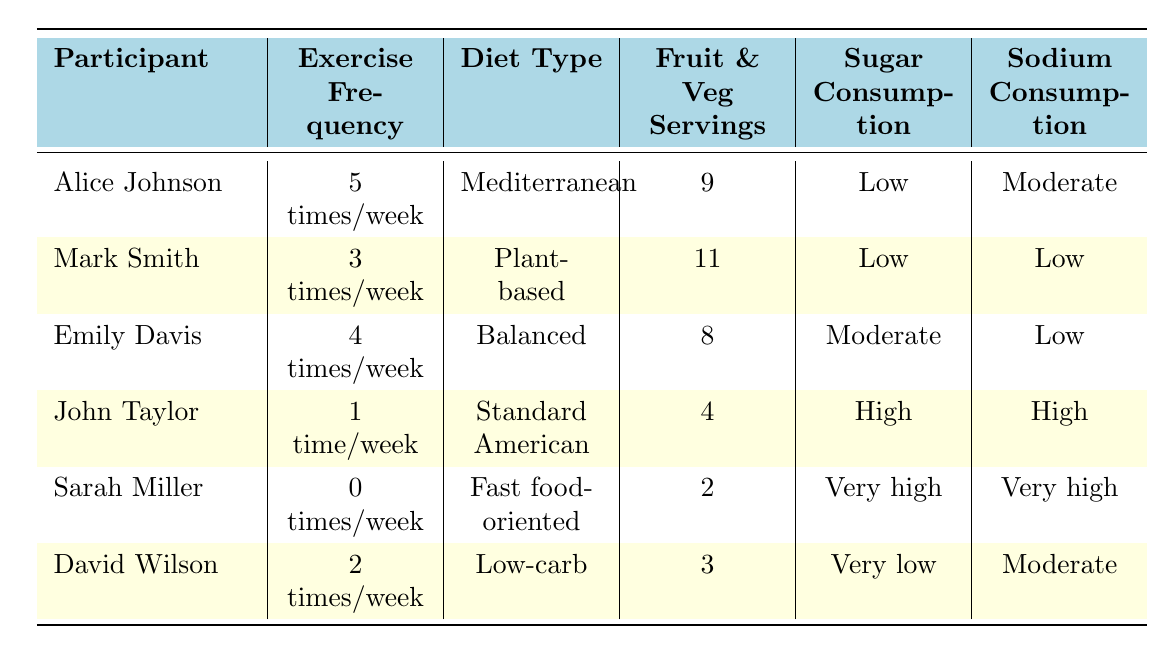What is the exercise frequency of Alice Johnson? By looking at the table, Alice Johnson is listed, and her corresponding exercise frequency is stated as "5 times/week."
Answer: 5 times/week Which participant has the highest sugar consumption? Reviewing the sugar consumption column, Sarah Miller is noted to have "very high" sugar consumption, which is higher than all others listed.
Answer: Sarah Miller What is the total number of fruit and vegetable servings for Mark Smith? The table shows that Mark Smith has 6 servings of fruits and 5 servings of vegetables, so the total is 6 + 5 = 11.
Answer: 11 Is there anyone who exercises more than 4 times a week? Looking at the exercise frequency, only Alice Johnson has an exercise frequency of "5 times/week," so she is the only one with that frequency.
Answer: Yes What is the average number of fruit and vegetable servings for all participants? To find the average, sum the fruit and vegetable servings: 9 (Alice) + 11 (Mark) + 8 (Emily) + 4 (John) + 2 (Sarah) + 3 (David) = 37; there are 6 participants, so the average is 37/6 ≈ 6.17.
Answer: Approximately 6.17 Which diet type has the least fruit and vegetable servings? The table shows that Sarah Miller's "Fast food-oriented" diet has the least servings with only 2.
Answer: Fast food-oriented How many participants have low sodium consumption? By checking the sodium consumption column, it indicates that Alice Johnson and Mark Smith both have "moderate" or "low" sodium consumption, totaling 3 participants (Alice, Mark, Emily) having low sodium consumption.
Answer: 3 Who consumes the least number of whole grains? The lowest number of whole grains servings is 0, which corresponds to David Wilson's "Low-carb" diet as per the table.
Answer: David Wilson What is the difference in fruit and vegetable servings between Emily Davis and John Taylor? Emily has 8 servings and John has 4, thus the difference is 8 - 4 = 4 servings.
Answer: 4 servings Are there any participants with a sedentary lifestyle who have low sugar consumption? Sarah Miller is sedentary and has very high sugar consumption, while David Wilson exercises 2 times/week and has very low sugar consumption. Therefore, there are no purely sedentary participants listed with low sugar consumption.
Answer: No 